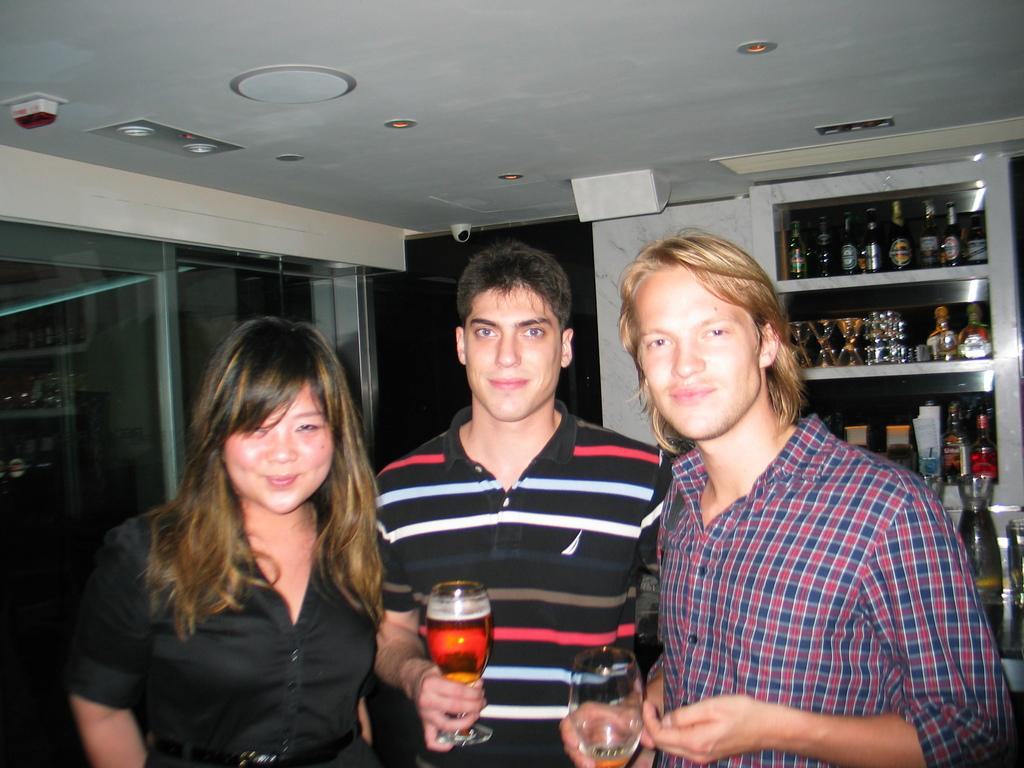What activity are the two men and the woman engaged in, in the image? The two men are standing and holding wine glasses, while the woman is not visible in the provided facts. What objects are the two men holding in their hands? The two men are holding wine glasses in their hands. Are there any bottles visible in the image? Yes, there are bottles visible in the image. What type of volleyball is being played in the image? There is no volleyball present in the image. Can you describe the intricate details of the wine glasses being held by the two men? The provided facts do not mention any specific details about the wine glasses. 